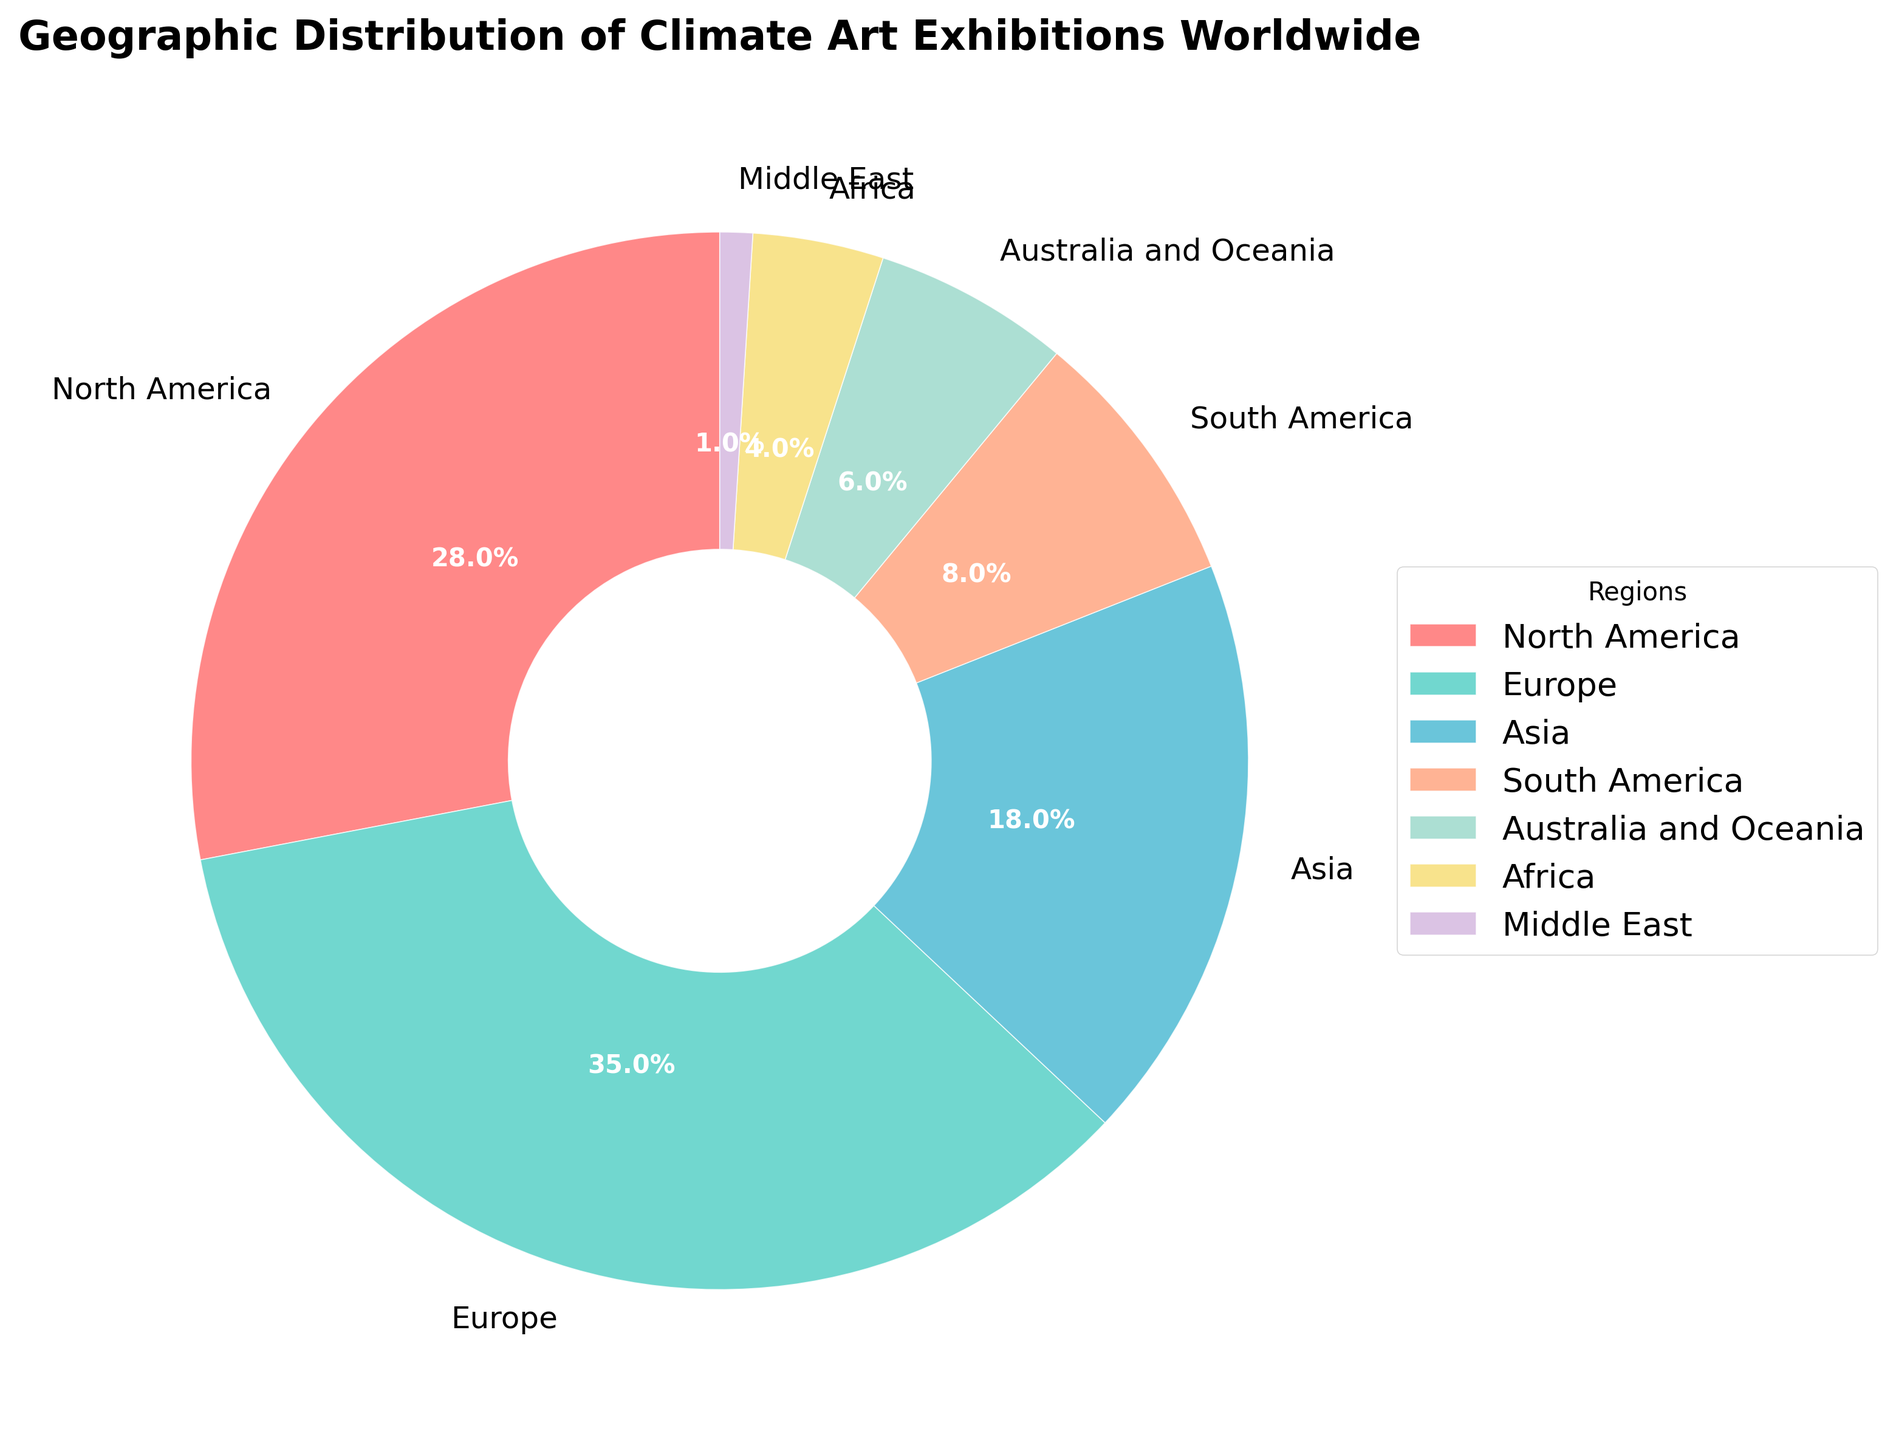1. Which region has the highest percentage of climate art exhibitions? The pie chart shows that Europe has the largest segment, which represents the highest percentage of climate art exhibitions.
Answer: Europe 2. Which two regions combined account for more than 50% of the climate art exhibitions? By adding up the percentages, North America (28%) and Europe (35%) together sum up to 63%, which is more than 50%.
Answer: North America and Europe 3. What is the difference in the percentage of climate art exhibitions between Asia and South America? Asia has 18% and South America has 8%; the difference is 18% - 8% = 10%.
Answer: 10% 4. How many regions have a lower percentage of climate art exhibitions than Australia and Oceania? Australia and Oceania have 6%. The regions with lesser percentages are Africa (4%) and the Middle East (1%). Hence, there are 2 regions.
Answer: 2 5. What is the combined percentage of climate art exhibitions in Africa, the Middle East, and South America? Adding these regions together: Africa (4%) + Middle East (1%) + South America (8%) = 13%.
Answer: 13% 6. What percentage of climate art exhibitions does Asia have when compared to the total of North America and Europe? Asia has 18%. North America and Europe together account for 28% + 35% = 63%. The percentage of Asia compared to them is (18/63) * 100 ≈ 28.6%.
Answer: 28.6% 7. How much larger is the percentage of climate art exhibitions in Europe compared to Australia and Oceania? Europe has 35%, and Australia and Oceania have 6%. The difference is 35% - 6% = 29%.
Answer: 29% 8. Which region is represented by the wedge with a yellow hue? The legend shows that Africa is represented by the yellow hue.
Answer: Africa 9. What is the combined percentage of climate art exhibitions in North America, South America, and Australia and Oceania? Adding these percentages: North America (28%) + South America (8%) + Australia and Oceania (6%) = 42%.
Answer: 42% 